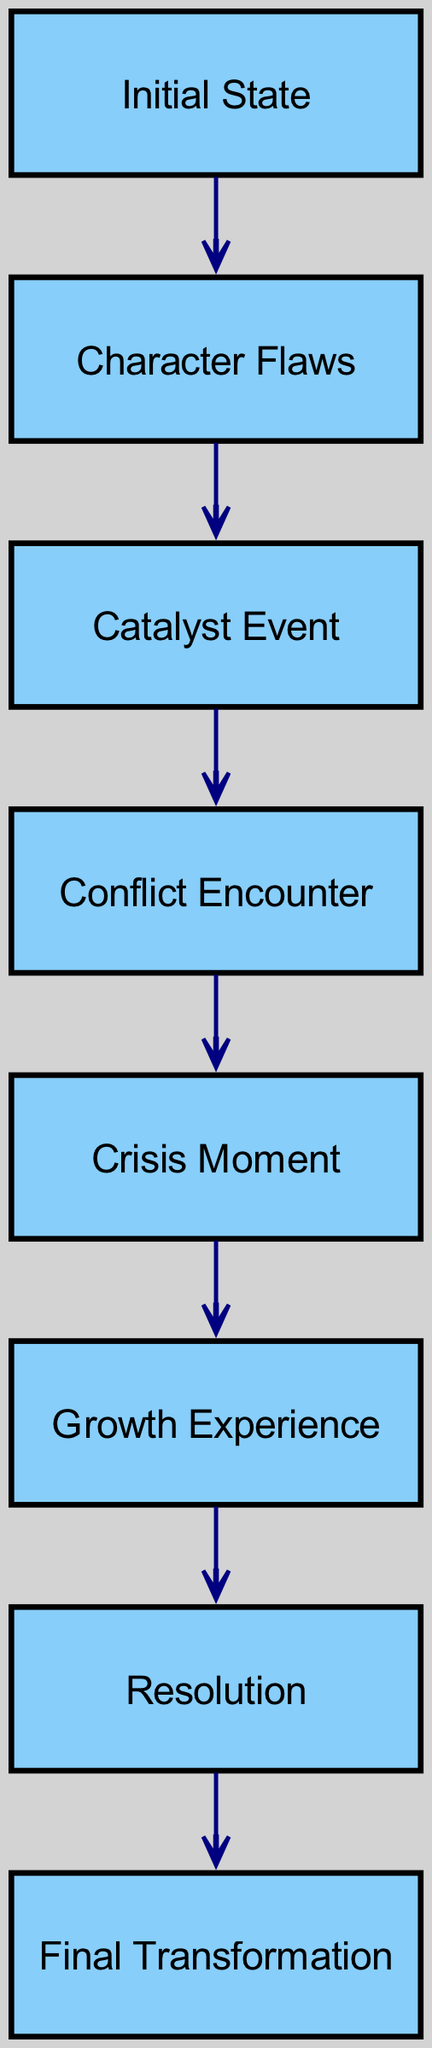What is the first node in the character development arc? The first node represented in the diagram is labeled "Initial State". This can be identified by locating the node with ID "1" at the beginning of the directed graph.
Answer: Initial State How many nodes are present in the diagram? The diagram consists of a total of 8 nodes based on the data provided. This can be counted directly from the nodes section of the data.
Answer: 8 What is the final transformation in the protagonist's development? The last node in the arc is labeled "Final Transformation". It is the endpoint of the flow and can be found at the end of the diagram.
Answer: Final Transformation What comes after the crisis moment? After the "Crisis Moment" represented by node "5", the next node in the sequence is "Growth Experience", indicating a clear progression in the character's development.
Answer: Growth Experience Which node represents a significant turning point in the character's journey? The "Catalyst Event" node, identified by ID "3", is a critical turning point as it triggers subsequent events in the narrative leading to character change.
Answer: Catalyst Event Which nodes are connected directly to the "Conflict Encounter"? The "Conflict Encounter" node is connected directly to two nodes: "Catalyst Event" (previous) and "Crisis Moment" (next). This connection shows the flow of events leading into and out of this stage.
Answer: Catalyst Event, Crisis Moment How many edges lead from the initial state to the final transformation? There are a total of 7 edges leading from "Initial State" to "Final Transformation", representing the various stages of character development through direct connections in the graph.
Answer: 7 What is the relationship between character flaws and the catalyst event? The relationship indicates progression, where nodes "Character Flaws" (2) leads to "Catalyst Event" (3), highlighting that the flaws set the stage for the event to occur next.
Answer: Leads to 